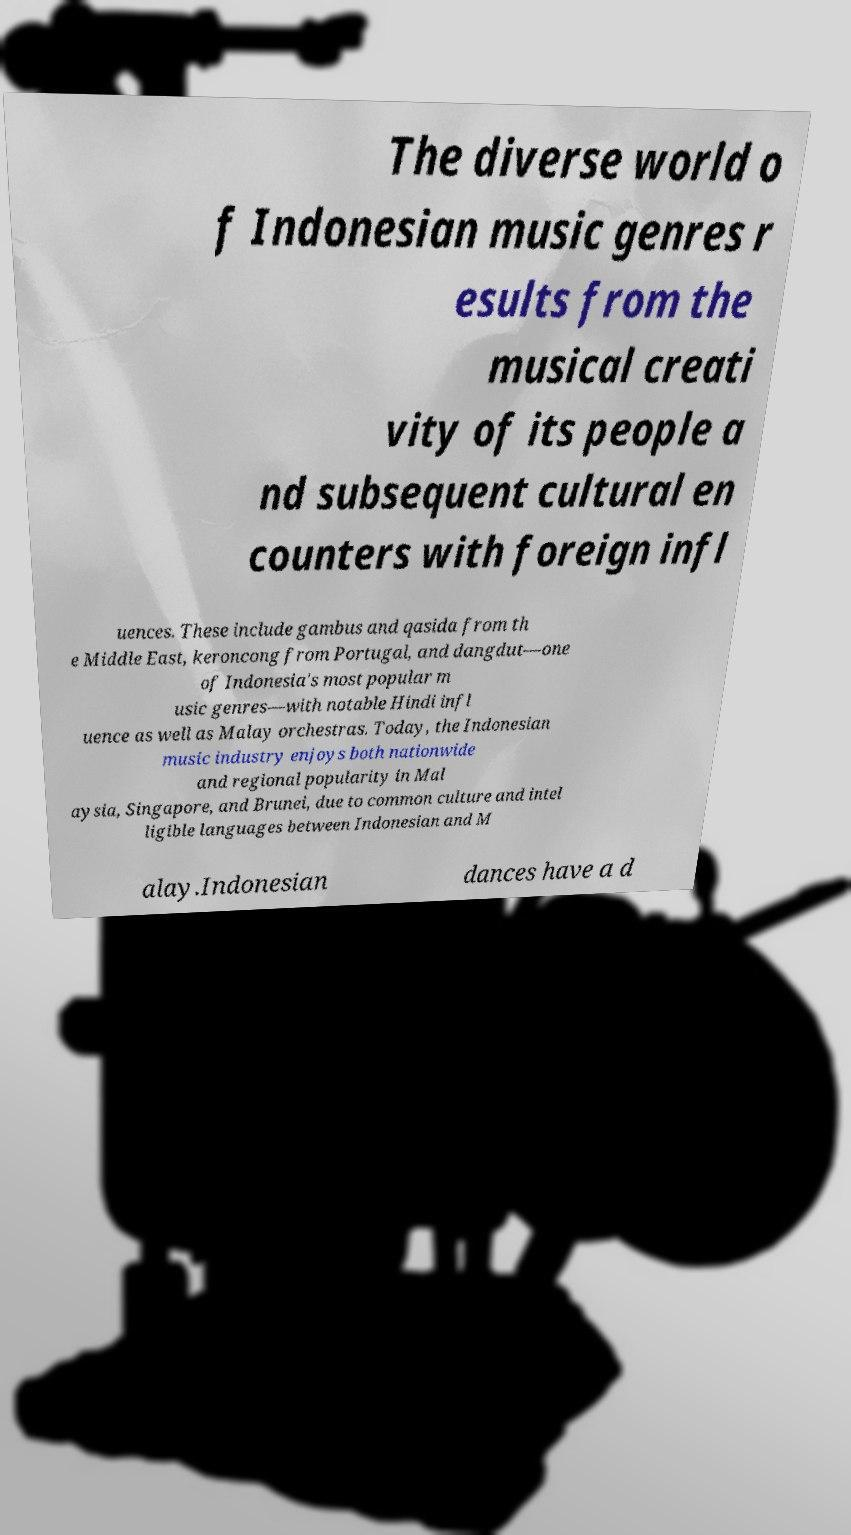I need the written content from this picture converted into text. Can you do that? The diverse world o f Indonesian music genres r esults from the musical creati vity of its people a nd subsequent cultural en counters with foreign infl uences. These include gambus and qasida from th e Middle East, keroncong from Portugal, and dangdut—one of Indonesia's most popular m usic genres—with notable Hindi infl uence as well as Malay orchestras. Today, the Indonesian music industry enjoys both nationwide and regional popularity in Mal aysia, Singapore, and Brunei, due to common culture and intel ligible languages between Indonesian and M alay.Indonesian dances have a d 